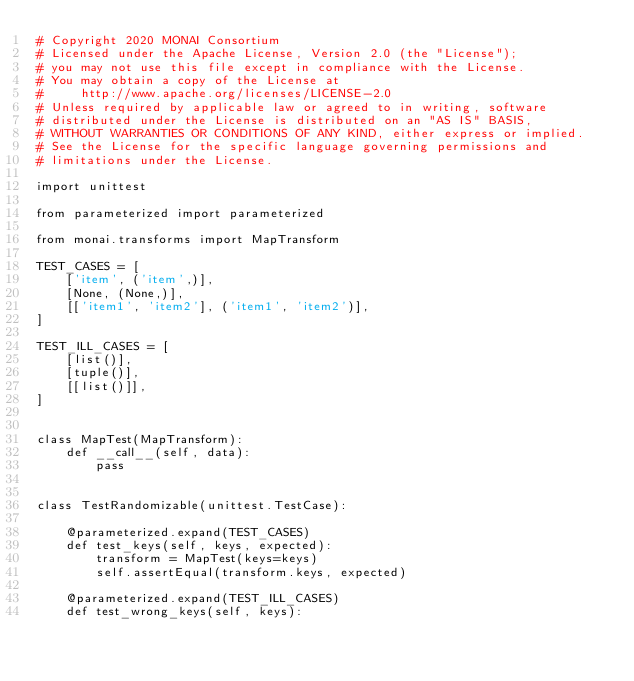<code> <loc_0><loc_0><loc_500><loc_500><_Python_># Copyright 2020 MONAI Consortium
# Licensed under the Apache License, Version 2.0 (the "License");
# you may not use this file except in compliance with the License.
# You may obtain a copy of the License at
#     http://www.apache.org/licenses/LICENSE-2.0
# Unless required by applicable law or agreed to in writing, software
# distributed under the License is distributed on an "AS IS" BASIS,
# WITHOUT WARRANTIES OR CONDITIONS OF ANY KIND, either express or implied.
# See the License for the specific language governing permissions and
# limitations under the License.

import unittest

from parameterized import parameterized

from monai.transforms import MapTransform

TEST_CASES = [
    ['item', ('item',)],
    [None, (None,)],
    [['item1', 'item2'], ('item1', 'item2')],
]

TEST_ILL_CASES = [
    [list()],
    [tuple()],
    [[list()]],
]


class MapTest(MapTransform):
    def __call__(self, data):
        pass


class TestRandomizable(unittest.TestCase):

    @parameterized.expand(TEST_CASES)
    def test_keys(self, keys, expected):
        transform = MapTest(keys=keys)
        self.assertEqual(transform.keys, expected)

    @parameterized.expand(TEST_ILL_CASES)
    def test_wrong_keys(self, keys):</code> 